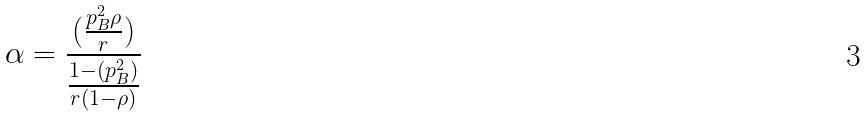Convert formula to latex. <formula><loc_0><loc_0><loc_500><loc_500>\alpha = \frac { ( \frac { p _ { B } ^ { 2 } \rho } { r } ) } { \frac { 1 - ( p _ { B } ^ { 2 } ) } { r ( 1 - \rho ) } }</formula> 